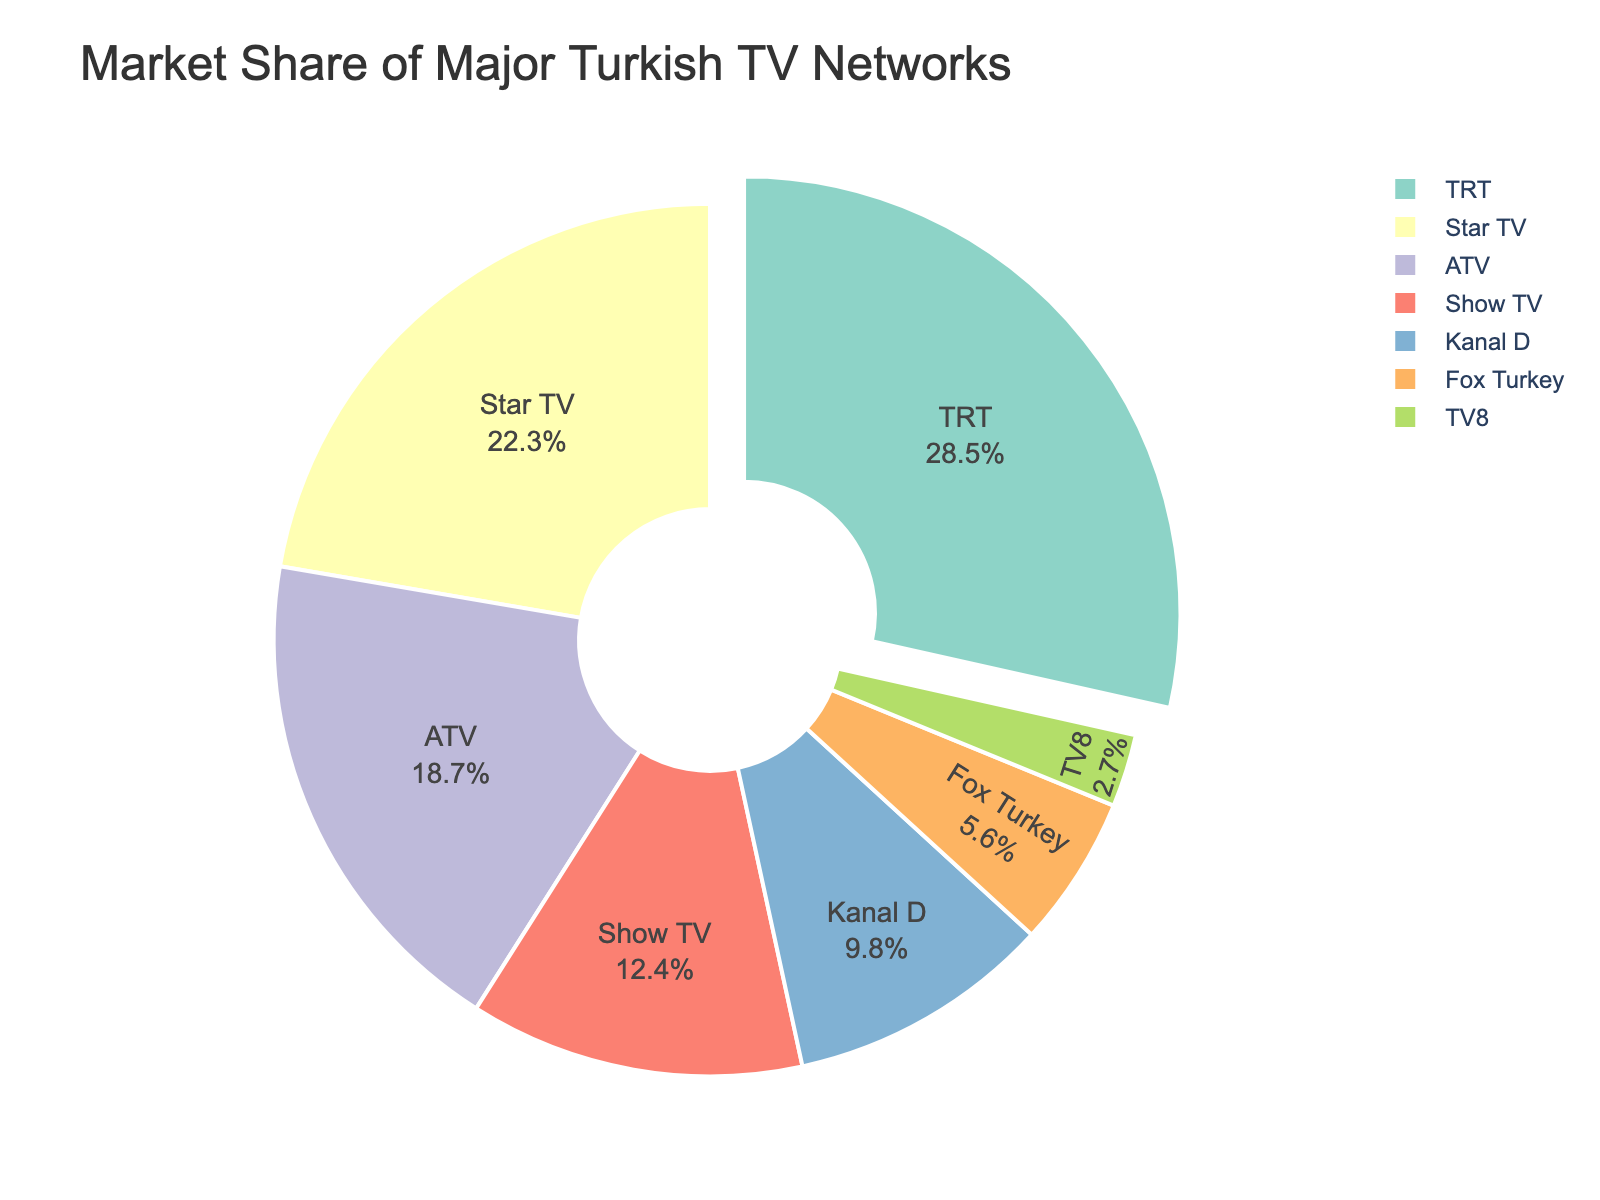Which network has the largest market share? Find the sector of the pie chart with the highest percentage. The label shows TRT with 28.5%.
Answer: TRT Which network has the smallest market share? Identify the sector of the pie chart with the smallest percentage of the total. The label shows TV8 with 2.7%.
Answer: TV8 What is the combined market share of Star TV and ATV? Add the market shares of Star TV (22.3%) and ATV (18.7%). The result is 22.3 + 18.7 = 41%.
Answer: 41% How much larger is TRT's market share compared to Kanal D's? Subtract Kanal D's market share (9.8%) from TRT's market share (28.5%). The difference is 28.5 - 9.8 = 18.7%.
Answer: 18.7% What is the average market share of Show TV and Fox Turkey? Add the market shares of Show TV (12.4%) and Fox Turkey (5.6%), then divide by 2. The result is (12.4 + 5.6)/2 = 9%.
Answer: 9% Which two networks together have a market share closest to that of TRT? Compare the market share of TRT (28.5%) with all possible pairs. The pair Star TV and ATV combined have 22.3% + 18.7% = 41%, which is close to TRT's share.
Answer: Star TV and ATV If TV8's market share doubled, would it be larger than Fox Turkey's market share? Double TV8's market share (2.7%) to get 5.4%. Compare 5.4% to Fox Turkey's share (5.6%). 5.4% is slightly less than 5.6%.
Answer: No Which networks have a market share greater than 20%? Identify the sectors of the pie chart with percentages greater than 20%. They are TRT with 28.5% and Star TV with 22.3%.
Answer: TRT and Star TV If the market shares of Kanal D and TV8 combined, would it exceed that of Show TV? Add the market share of Kanal D (9.8%) and TV8 (2.7%), then compare the sum (12.5%) to Show TV's share (12.4%). 12.5% is slightly more than 12.4%.
Answer: Yes What percentage of the market do the top three networks control? Add the market shares of the top three networks: TRT (28.5%), Star TV (22.3%), and ATV (18.7%). The result is 28.5 + 22.3 + 18.7 = 69.5%.
Answer: 69.5% 